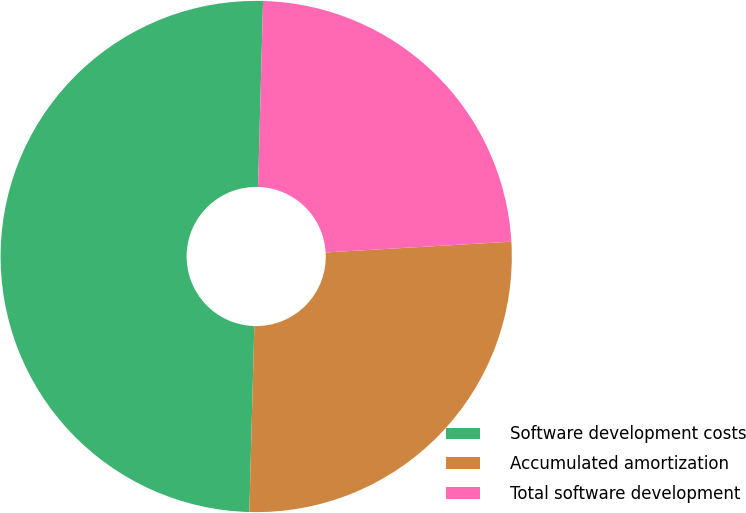Convert chart to OTSL. <chart><loc_0><loc_0><loc_500><loc_500><pie_chart><fcel>Software development costs<fcel>Accumulated amortization<fcel>Total software development<nl><fcel>50.0%<fcel>26.35%<fcel>23.65%<nl></chart> 